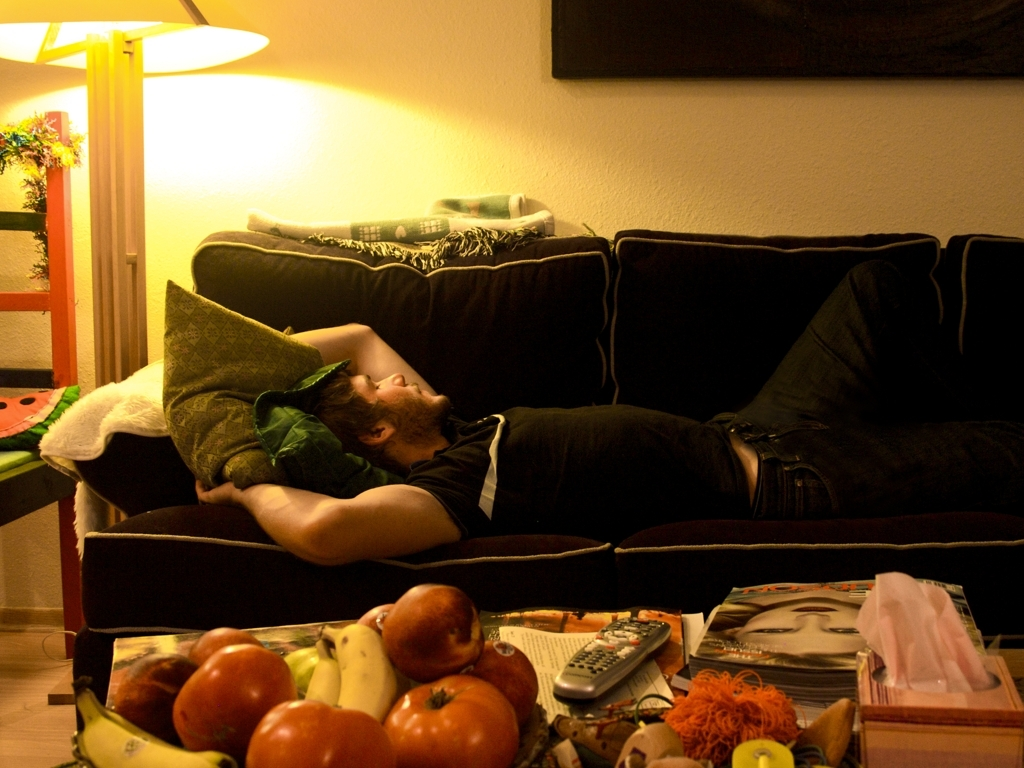What kind of mood does this setting suggest? The warm lighting and cozy furnishings create a homely and relaxing atmosphere indicative of a tranquil evening in. 